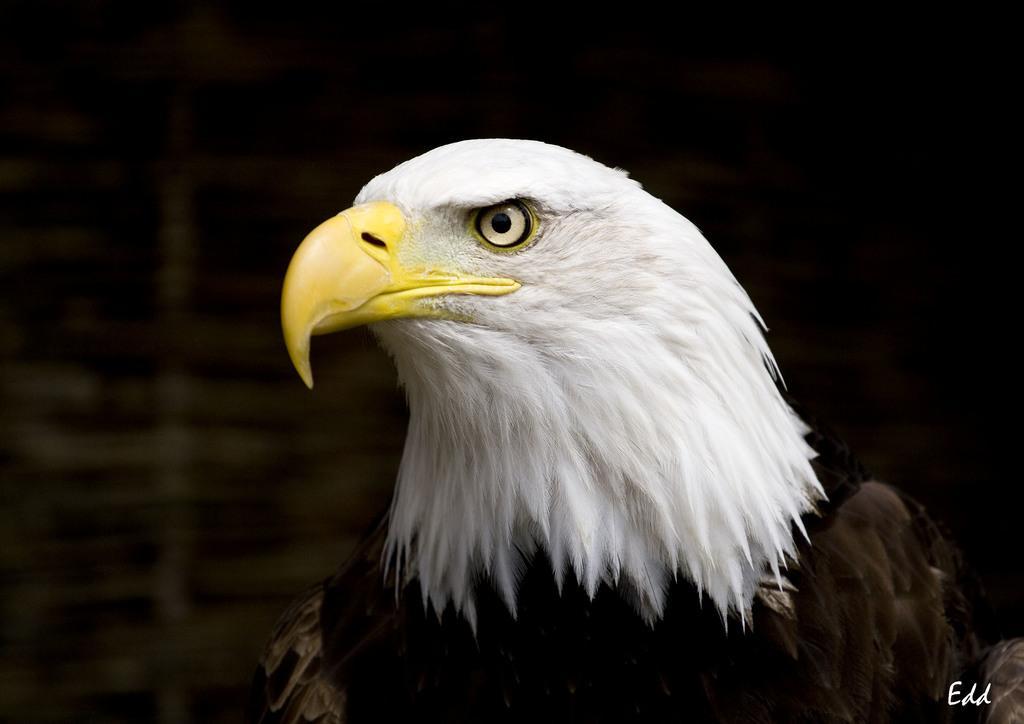Describe this image in one or two sentences. In the picture I can see an eagle. The background of the image is dark. On the bottom right corner of the image I can see a watermark. 